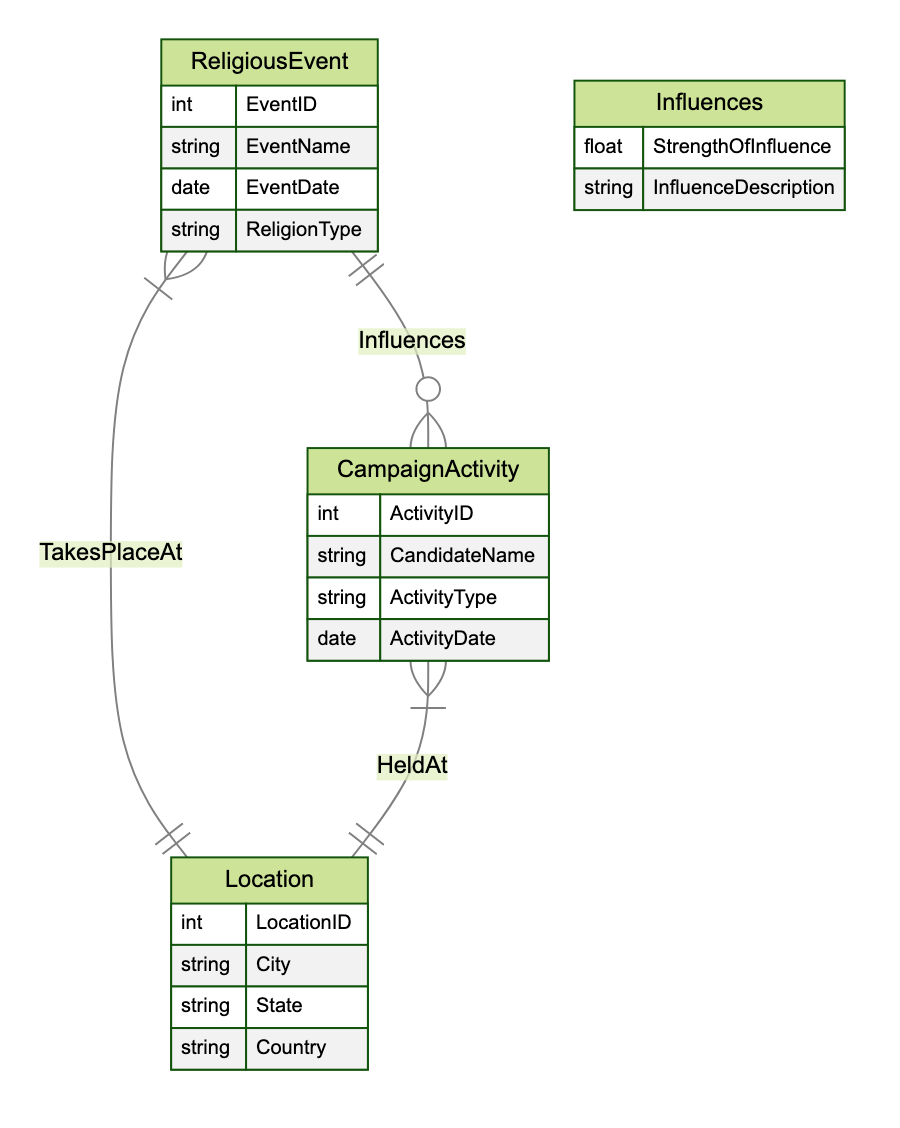What is the cardinality of the relationship between ReligiousEvent and CampaignActivity? The relationship between ReligiousEvent and CampaignActivity is labeled as "OneToMany," meaning one ReligiousEvent can influence many CampaignActivities.
Answer: OneToMany What type of relationship exists between CampaignActivity and Location? The relationship between CampaignActivity and Location is labeled as "HeldAt," indicating that each CampaignActivity takes place at one Location while possibly multiple CampaignActivities can be held at the same Location.
Answer: HeldAt How many attributes does the ReligiousEvent entity have? The ReligiousEvent entity has four attributes: EventID, EventName, EventDate, and ReligionType.
Answer: Four Which entity has the attribute ActivityType? The attribute ActivityType belongs to the CampaignActivity entity, which captures different types of campaign activities by the candidate.
Answer: CampaignActivity What is the StrengthOfInfluence attribute related to? The StrengthOfInfluence attribute is related to the Influences relationship between ReligiousEvent and CampaignActivity, quantifying how much one influences the other.
Answer: Influences How many entities are present in the diagram? The diagram contains three entities: ReligiousEvent, CampaignActivity, and Location.
Answer: Three Which entity could represent a church event? The ReligiousEvent entity could represent a church event since it encompasses various types of religious events across different religions.
Answer: ReligiousEvent If a CampaignActivity is held in a specific Location, is there a potential ReligiousEvent that could influence it? Yes, there is a potential for a ReligiousEvent to influence a CampaignActivity held at the same Location, as per the relationship between the two entities highlighted in the diagram.
Answer: Yes What describes the relationship between ReligiousEvent and Location? The relationship between ReligiousEvent and Location is specified as "TakesPlaceAt," indicating that multiple ReligiousEvents can take place at a single Location.
Answer: TakesPlaceAt How many attributes does the Location entity have? The Location entity has four attributes: LocationID, City, State, and Country.
Answer: Four 